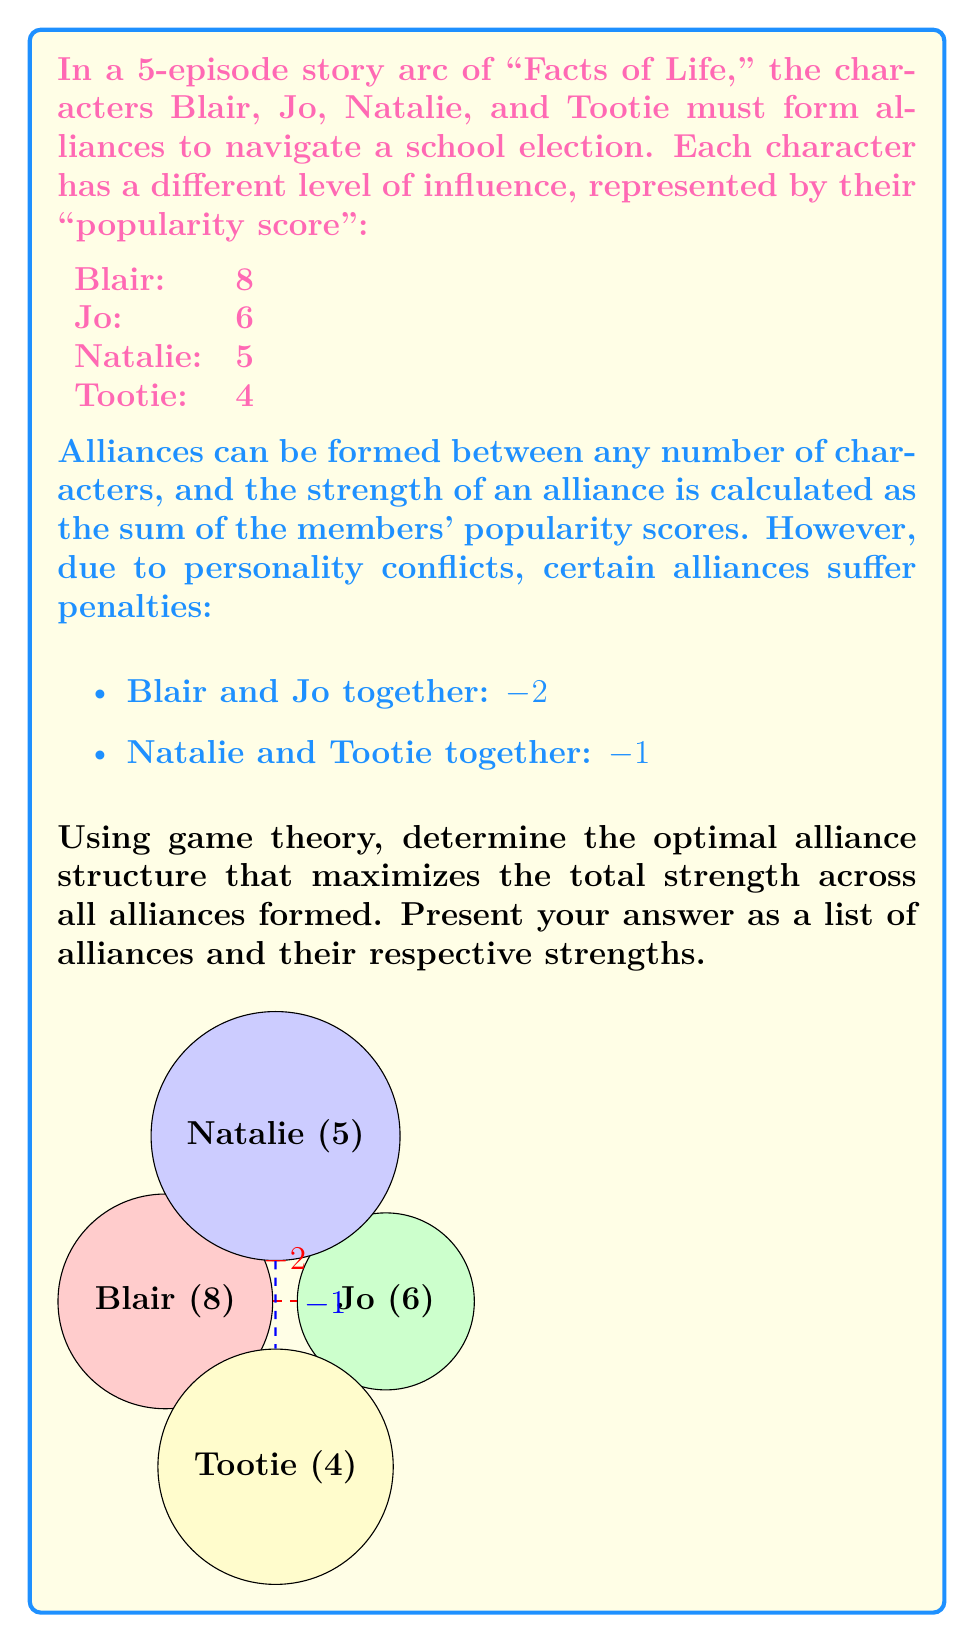Teach me how to tackle this problem. To solve this problem, we need to consider all possible alliance structures and calculate their total strengths. Let's approach this step-by-step:

1) First, list all possible alliance structures:
   - Four individual alliances
   - Three alliances (one pair, two individuals)
   - Two alliances (two pairs)
   - Two alliances (one group of three, one individual)
   - One alliance (all four together)

2) Calculate the strength of each possible structure:

   a) Four individual alliances:
      Blair: 8, Jo: 6, Natalie: 5, Tootie: 4
      Total strength: $8 + 6 + 5 + 4 = 23$

   b) Three alliances:
      - Blair+Jo (6+8-2=12), Natalie (5), Tootie (4). Total: $12 + 5 + 4 = 21$
      - Blair+Natalie (13), Jo (6), Tootie (4). Total: $13 + 6 + 4 = 23$
      - Blair+Tootie (12), Jo (6), Natalie (5). Total: $12 + 6 + 5 = 23$
      - Jo+Natalie (11), Blair (8), Tootie (4). Total: $11 + 8 + 4 = 23$
      - Jo+Tootie (10), Blair (8), Natalie (5). Total: $10 + 8 + 5 = 23$
      - Natalie+Tootie (5+4-1=8), Blair (8), Jo (6). Total: $8 + 8 + 6 = 22$

   c) Two alliances (two pairs):
      - Blair+Jo (12), Natalie+Tootie (8). Total: $12 + 8 = 20$
      - Blair+Natalie (13), Jo+Tootie (10). Total: $13 + 10 = 23$
      - Blair+Tootie (12), Jo+Natalie (11). Total: $12 + 11 = 23$

   d) Two alliances (one group of three, one individual):
      - Blair+Jo+Natalie (19), Tootie (4). Total: $19 + 4 = 23$
      - Blair+Jo+Tootie (18), Natalie (5). Total: $18 + 5 = 23$
      - Blair+Natalie+Tootie (17), Jo (6). Total: $17 + 6 = 23$
      - Jo+Natalie+Tootie (15), Blair (8). Total: $15 + 8 = 23$

   e) One alliance (all four together):
      Blair+Jo+Natalie+Tootie: $8 + 6 + 5 + 4 - 2 - 1 = 20$

3) The maximum total strength achieved is 23, which occurs in multiple scenarios.

4) Among these optimal scenarios, the one that forms the strongest individual alliance while maintaining the maximum total strength is:
   Blair+Natalie (13), Jo (6), Tootie (4)

This structure maximizes the strength of the largest alliance (13) while keeping the total strength at the optimal value (23).
Answer: Blair+Natalie (13), Jo (6), Tootie (4) 